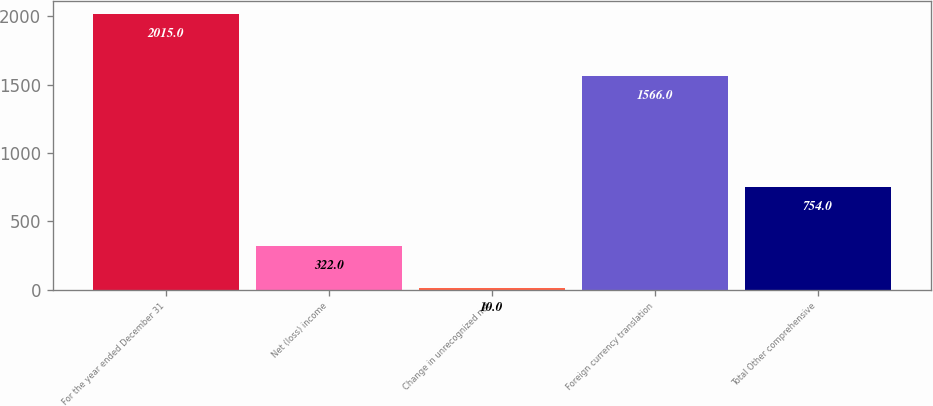<chart> <loc_0><loc_0><loc_500><loc_500><bar_chart><fcel>For the year ended December 31<fcel>Net (loss) income<fcel>Change in unrecognized net<fcel>Foreign currency translation<fcel>Total Other comprehensive<nl><fcel>2015<fcel>322<fcel>10<fcel>1566<fcel>754<nl></chart> 